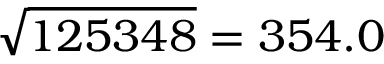Convert formula to latex. <formula><loc_0><loc_0><loc_500><loc_500>{ \sqrt { 1 2 5 3 4 8 } } = 3 5 4 . 0</formula> 